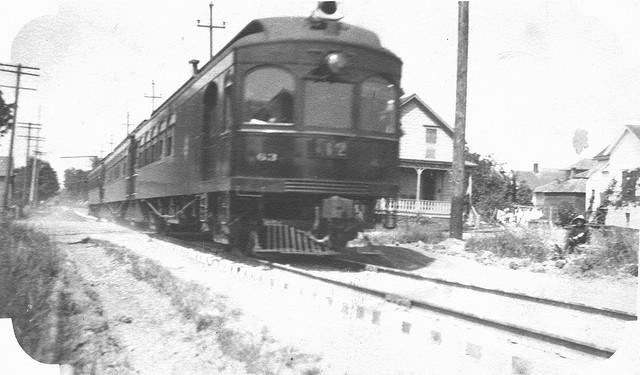Is this photo digital?
Give a very brief answer. No. Is this a color or black and white photo?
Be succinct. Black and white. Has it been snowing?
Answer briefly. Yes. 